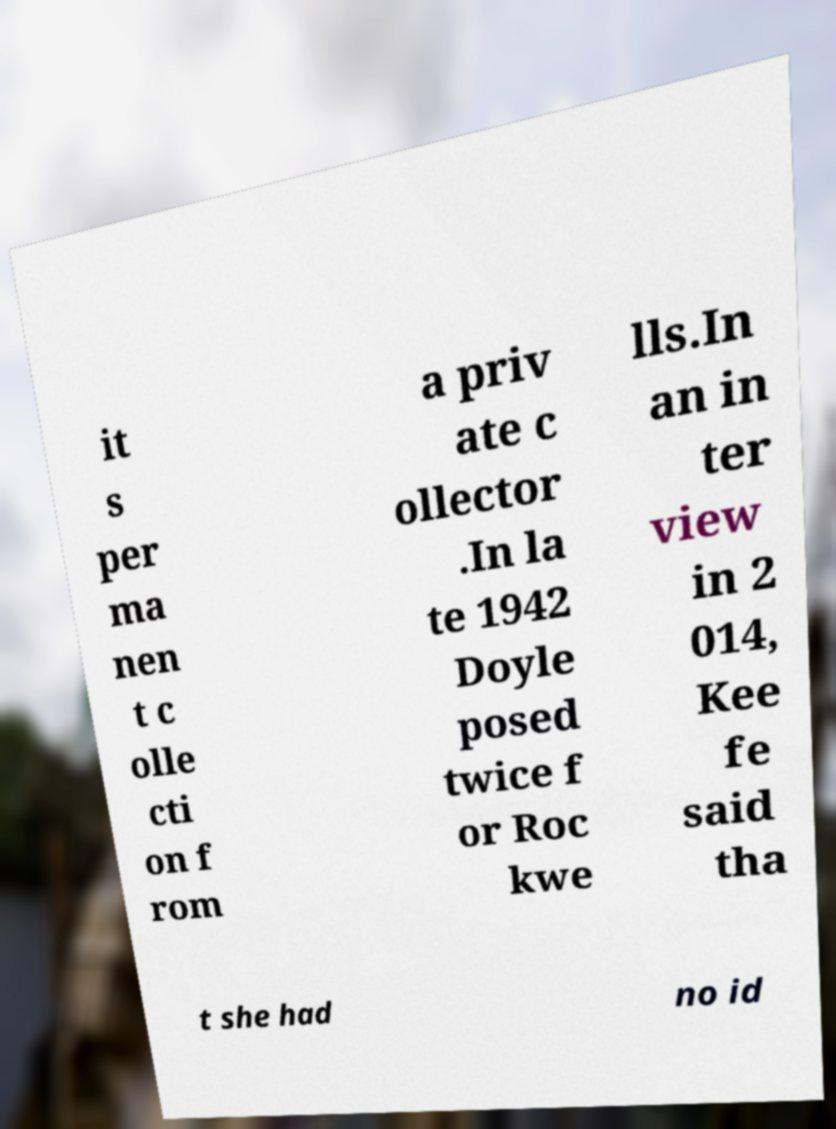Please read and relay the text visible in this image. What does it say? it s per ma nen t c olle cti on f rom a priv ate c ollector .In la te 1942 Doyle posed twice f or Roc kwe lls.In an in ter view in 2 014, Kee fe said tha t she had no id 